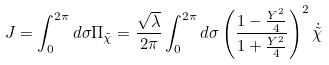Convert formula to latex. <formula><loc_0><loc_0><loc_500><loc_500>J = \int _ { 0 } ^ { 2 \pi } d \sigma \Pi _ { \tilde { \chi } } = \frac { \sqrt { \lambda } } { 2 \pi } \int _ { 0 } ^ { 2 \pi } d \sigma \left ( \frac { 1 - \frac { Y ^ { 2 } } { 4 } } { 1 + \frac { Y ^ { 2 } } { 4 } } \right ) ^ { 2 } \dot { \tilde { \chi } }</formula> 